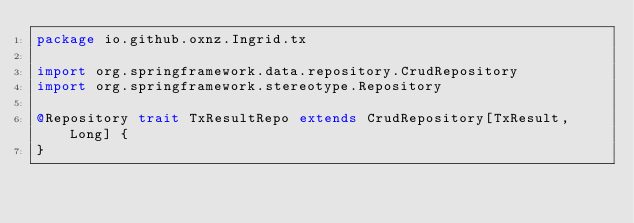<code> <loc_0><loc_0><loc_500><loc_500><_Scala_>package io.github.oxnz.Ingrid.tx

import org.springframework.data.repository.CrudRepository
import org.springframework.stereotype.Repository

@Repository trait TxResultRepo extends CrudRepository[TxResult, Long] {
}
</code> 